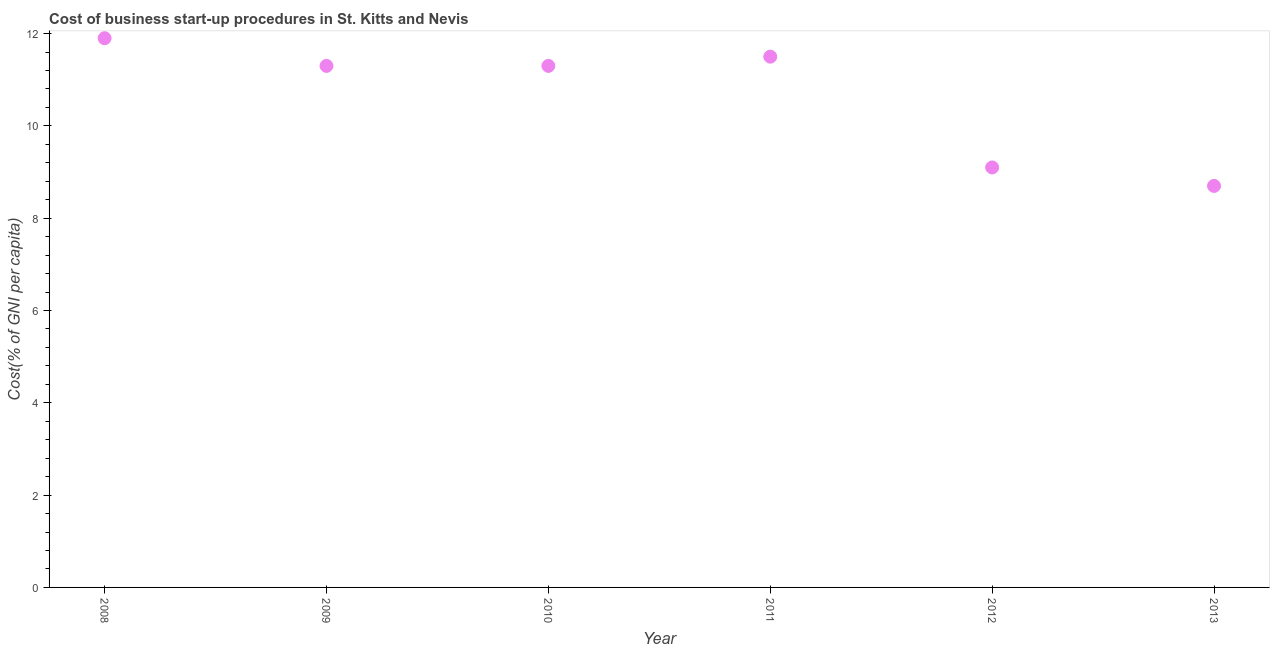What is the sum of the cost of business startup procedures?
Offer a very short reply. 63.8. What is the difference between the cost of business startup procedures in 2011 and 2012?
Your response must be concise. 2.4. What is the average cost of business startup procedures per year?
Provide a short and direct response. 10.63. In how many years, is the cost of business startup procedures greater than 7.2 %?
Ensure brevity in your answer.  6. What is the ratio of the cost of business startup procedures in 2009 to that in 2012?
Provide a succinct answer. 1.24. Is the cost of business startup procedures in 2010 less than that in 2013?
Offer a terse response. No. What is the difference between the highest and the second highest cost of business startup procedures?
Your answer should be very brief. 0.4. What is the difference between the highest and the lowest cost of business startup procedures?
Provide a succinct answer. 3.2. In how many years, is the cost of business startup procedures greater than the average cost of business startup procedures taken over all years?
Provide a succinct answer. 4. Does the graph contain any zero values?
Provide a succinct answer. No. What is the title of the graph?
Offer a very short reply. Cost of business start-up procedures in St. Kitts and Nevis. What is the label or title of the Y-axis?
Your response must be concise. Cost(% of GNI per capita). What is the Cost(% of GNI per capita) in 2009?
Provide a short and direct response. 11.3. What is the Cost(% of GNI per capita) in 2011?
Your answer should be compact. 11.5. What is the Cost(% of GNI per capita) in 2012?
Keep it short and to the point. 9.1. What is the difference between the Cost(% of GNI per capita) in 2008 and 2009?
Provide a succinct answer. 0.6. What is the difference between the Cost(% of GNI per capita) in 2008 and 2010?
Keep it short and to the point. 0.6. What is the difference between the Cost(% of GNI per capita) in 2008 and 2012?
Offer a very short reply. 2.8. What is the difference between the Cost(% of GNI per capita) in 2008 and 2013?
Your answer should be compact. 3.2. What is the difference between the Cost(% of GNI per capita) in 2009 and 2010?
Offer a terse response. 0. What is the difference between the Cost(% of GNI per capita) in 2009 and 2013?
Offer a very short reply. 2.6. What is the difference between the Cost(% of GNI per capita) in 2010 and 2013?
Offer a terse response. 2.6. What is the difference between the Cost(% of GNI per capita) in 2011 and 2012?
Keep it short and to the point. 2.4. What is the difference between the Cost(% of GNI per capita) in 2011 and 2013?
Keep it short and to the point. 2.8. What is the difference between the Cost(% of GNI per capita) in 2012 and 2013?
Make the answer very short. 0.4. What is the ratio of the Cost(% of GNI per capita) in 2008 to that in 2009?
Offer a terse response. 1.05. What is the ratio of the Cost(% of GNI per capita) in 2008 to that in 2010?
Make the answer very short. 1.05. What is the ratio of the Cost(% of GNI per capita) in 2008 to that in 2011?
Ensure brevity in your answer.  1.03. What is the ratio of the Cost(% of GNI per capita) in 2008 to that in 2012?
Make the answer very short. 1.31. What is the ratio of the Cost(% of GNI per capita) in 2008 to that in 2013?
Your answer should be compact. 1.37. What is the ratio of the Cost(% of GNI per capita) in 2009 to that in 2010?
Give a very brief answer. 1. What is the ratio of the Cost(% of GNI per capita) in 2009 to that in 2011?
Give a very brief answer. 0.98. What is the ratio of the Cost(% of GNI per capita) in 2009 to that in 2012?
Give a very brief answer. 1.24. What is the ratio of the Cost(% of GNI per capita) in 2009 to that in 2013?
Offer a very short reply. 1.3. What is the ratio of the Cost(% of GNI per capita) in 2010 to that in 2012?
Your answer should be very brief. 1.24. What is the ratio of the Cost(% of GNI per capita) in 2010 to that in 2013?
Offer a very short reply. 1.3. What is the ratio of the Cost(% of GNI per capita) in 2011 to that in 2012?
Make the answer very short. 1.26. What is the ratio of the Cost(% of GNI per capita) in 2011 to that in 2013?
Provide a succinct answer. 1.32. What is the ratio of the Cost(% of GNI per capita) in 2012 to that in 2013?
Provide a short and direct response. 1.05. 